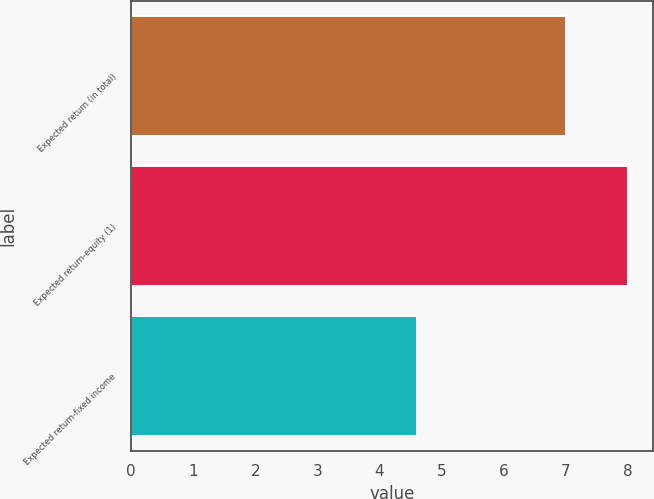<chart> <loc_0><loc_0><loc_500><loc_500><bar_chart><fcel>Expected return (in total)<fcel>Expected return-equity (1)<fcel>Expected return-fixed income<nl><fcel>7<fcel>8<fcel>4.6<nl></chart> 